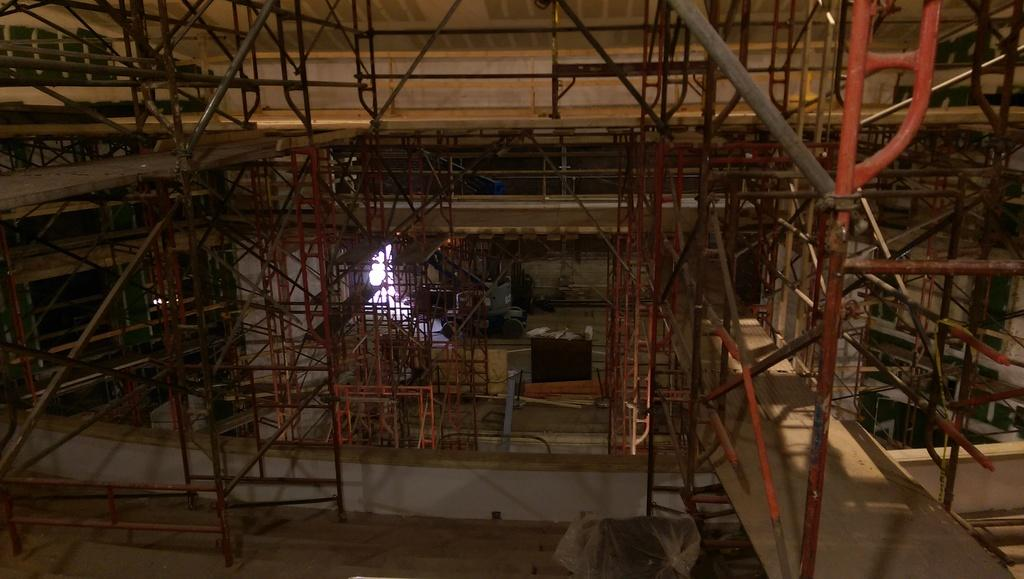What type of location is shown in the image? The image depicts a workshop. What materials can be seen in the workshop? There are many iron pipes and metal rods in the workshop. How often do the workers in the workshop rub the hydrant to keep it clean? There is no hydrant present in the image, so it is not possible to determine how often it is rubbed for cleaning. 